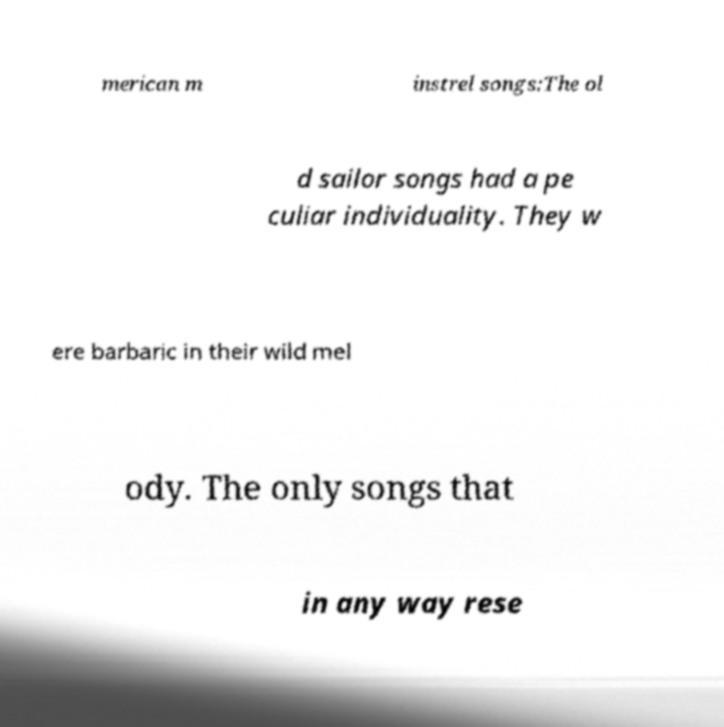Could you extract and type out the text from this image? merican m instrel songs:The ol d sailor songs had a pe culiar individuality. They w ere barbaric in their wild mel ody. The only songs that in any way rese 